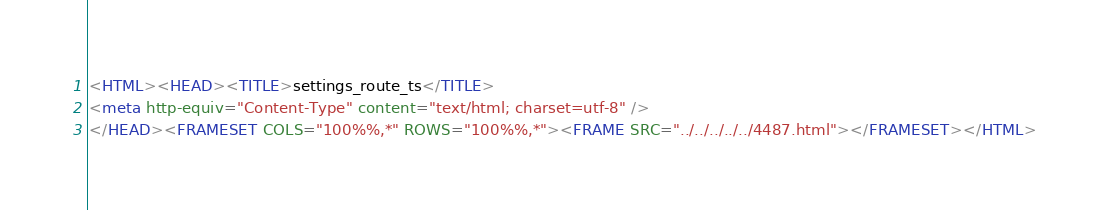Convert code to text. <code><loc_0><loc_0><loc_500><loc_500><_HTML_><HTML><HEAD><TITLE>settings_route_ts</TITLE>
<meta http-equiv="Content-Type" content="text/html; charset=utf-8" />
</HEAD><FRAMESET COLS="100%%,*" ROWS="100%%,*"><FRAME SRC="../../../../../4487.html"></FRAMESET></HTML>
</code> 